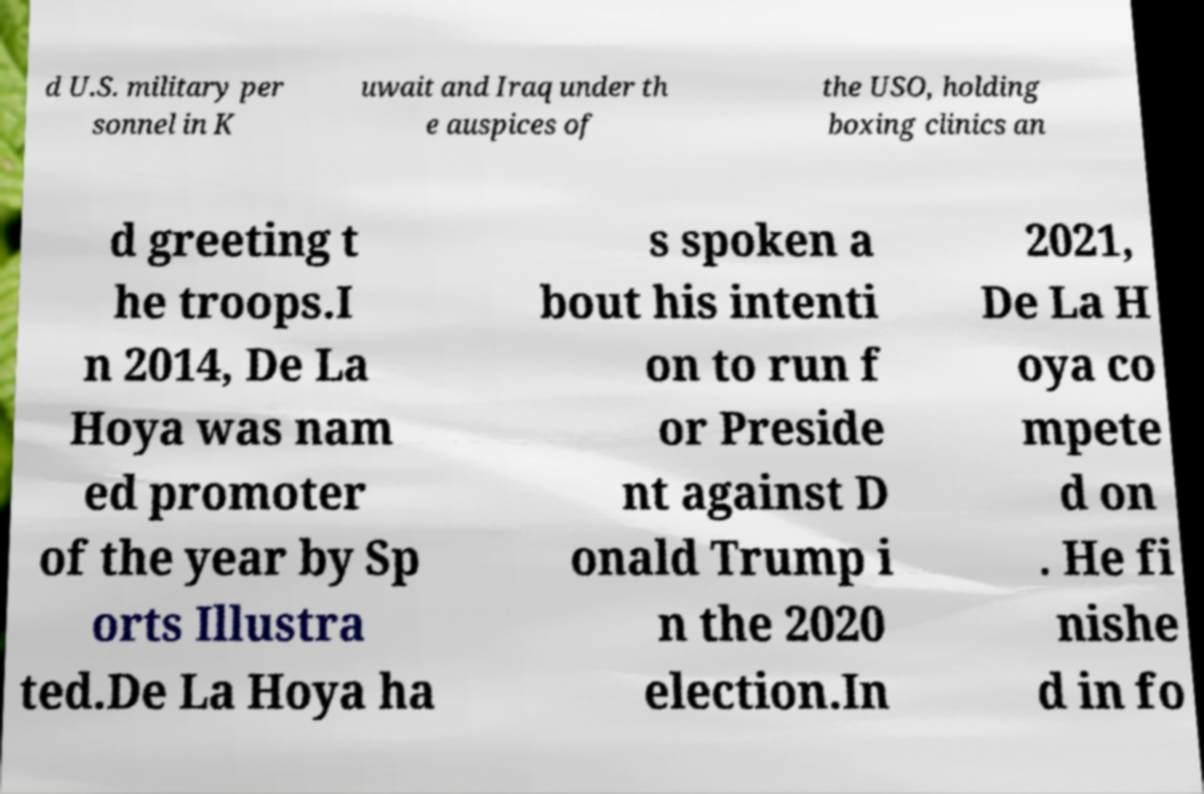Can you accurately transcribe the text from the provided image for me? d U.S. military per sonnel in K uwait and Iraq under th e auspices of the USO, holding boxing clinics an d greeting t he troops.I n 2014, De La Hoya was nam ed promoter of the year by Sp orts Illustra ted.De La Hoya ha s spoken a bout his intenti on to run f or Preside nt against D onald Trump i n the 2020 election.In 2021, De La H oya co mpete d on . He fi nishe d in fo 